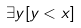Convert formula to latex. <formula><loc_0><loc_0><loc_500><loc_500>\exists y [ y < x ]</formula> 